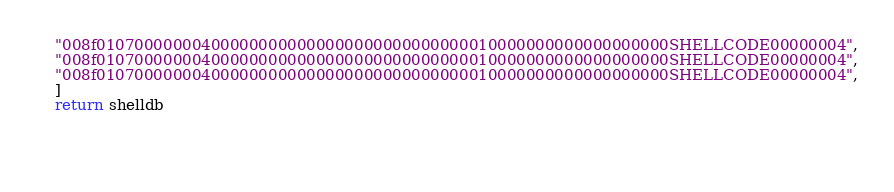<code> <loc_0><loc_0><loc_500><loc_500><_Python_>	"008f010700000004000000000000000000000000000010000000000000000000SHELLCODE00000004",
	"008f010700000004000000000000000000000000000010000000000000000000SHELLCODE00000004",
	"008f010700000004000000000000000000000000000010000000000000000000SHELLCODE00000004",
	]
	return shelldb


	</code> 